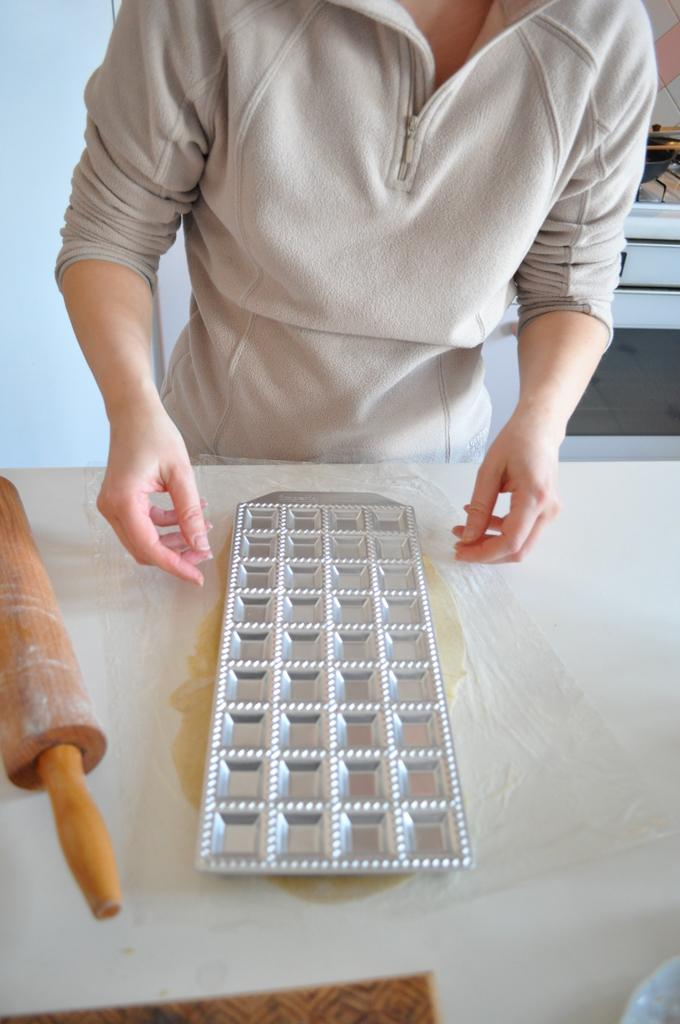What piece of furniture is present in the image? There is a table in the image. What is placed on the table? There is a tray on the table. What object can be seen besides the table and tray? There is a wooden stick in the image. What is the person near the table doing? The person is standing near the table and trying to hold the tray. Can you see any buckets in the image? There is no bucket present in the image. Is the person near the table being attacked by anyone? There is no indication of an attack in the image; the person is simply trying to hold the tray. 